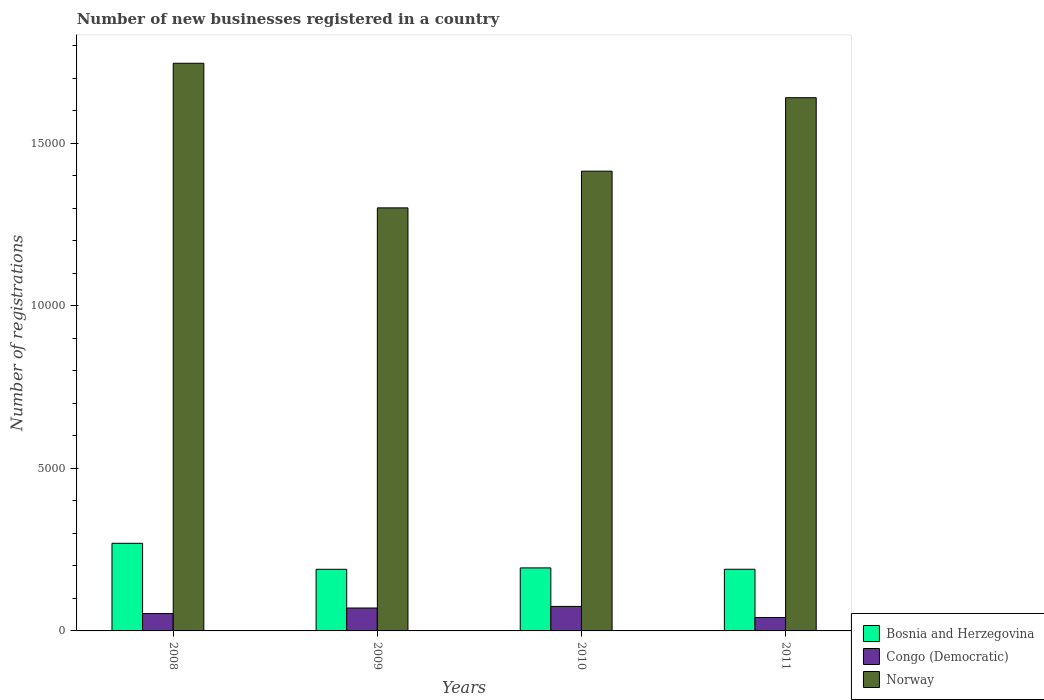How many different coloured bars are there?
Provide a short and direct response. 3. Are the number of bars per tick equal to the number of legend labels?
Ensure brevity in your answer.  Yes. How many bars are there on the 3rd tick from the right?
Offer a terse response. 3. What is the label of the 4th group of bars from the left?
Your answer should be very brief. 2011. In how many cases, is the number of bars for a given year not equal to the number of legend labels?
Give a very brief answer. 0. What is the number of new businesses registered in Bosnia and Herzegovina in 2009?
Your response must be concise. 1896. Across all years, what is the maximum number of new businesses registered in Bosnia and Herzegovina?
Offer a very short reply. 2696. Across all years, what is the minimum number of new businesses registered in Bosnia and Herzegovina?
Offer a very short reply. 1896. In which year was the number of new businesses registered in Norway maximum?
Offer a terse response. 2008. What is the total number of new businesses registered in Norway in the graph?
Ensure brevity in your answer.  6.10e+04. What is the difference between the number of new businesses registered in Bosnia and Herzegovina in 2009 and that in 2010?
Ensure brevity in your answer.  -43. What is the difference between the number of new businesses registered in Congo (Democratic) in 2008 and the number of new businesses registered in Bosnia and Herzegovina in 2010?
Give a very brief answer. -1405. What is the average number of new businesses registered in Congo (Democratic) per year?
Give a very brief answer. 601.5. In the year 2008, what is the difference between the number of new businesses registered in Congo (Democratic) and number of new businesses registered in Norway?
Offer a terse response. -1.69e+04. In how many years, is the number of new businesses registered in Norway greater than 9000?
Offer a very short reply. 4. What is the ratio of the number of new businesses registered in Congo (Democratic) in 2008 to that in 2011?
Offer a very short reply. 1.29. Is the number of new businesses registered in Norway in 2009 less than that in 2010?
Provide a succinct answer. Yes. What is the difference between the highest and the second highest number of new businesses registered in Bosnia and Herzegovina?
Provide a succinct answer. 757. What is the difference between the highest and the lowest number of new businesses registered in Norway?
Your response must be concise. 4449. What does the 1st bar from the left in 2011 represents?
Offer a terse response. Bosnia and Herzegovina. What does the 1st bar from the right in 2008 represents?
Make the answer very short. Norway. Is it the case that in every year, the sum of the number of new businesses registered in Congo (Democratic) and number of new businesses registered in Bosnia and Herzegovina is greater than the number of new businesses registered in Norway?
Provide a succinct answer. No. How many bars are there?
Ensure brevity in your answer.  12. Are all the bars in the graph horizontal?
Ensure brevity in your answer.  No. How many years are there in the graph?
Your answer should be compact. 4. What is the difference between two consecutive major ticks on the Y-axis?
Give a very brief answer. 5000. Does the graph contain any zero values?
Keep it short and to the point. No. Does the graph contain grids?
Your response must be concise. No. How many legend labels are there?
Ensure brevity in your answer.  3. What is the title of the graph?
Offer a very short reply. Number of new businesses registered in a country. Does "Middle East & North Africa (developing only)" appear as one of the legend labels in the graph?
Make the answer very short. No. What is the label or title of the X-axis?
Your answer should be compact. Years. What is the label or title of the Y-axis?
Keep it short and to the point. Number of registrations. What is the Number of registrations in Bosnia and Herzegovina in 2008?
Offer a terse response. 2696. What is the Number of registrations in Congo (Democratic) in 2008?
Offer a very short reply. 534. What is the Number of registrations of Norway in 2008?
Your answer should be compact. 1.75e+04. What is the Number of registrations in Bosnia and Herzegovina in 2009?
Make the answer very short. 1896. What is the Number of registrations of Congo (Democratic) in 2009?
Your response must be concise. 705. What is the Number of registrations in Norway in 2009?
Give a very brief answer. 1.30e+04. What is the Number of registrations in Bosnia and Herzegovina in 2010?
Offer a very short reply. 1939. What is the Number of registrations of Congo (Democratic) in 2010?
Provide a succinct answer. 754. What is the Number of registrations in Norway in 2010?
Your answer should be very brief. 1.41e+04. What is the Number of registrations of Bosnia and Herzegovina in 2011?
Your answer should be compact. 1897. What is the Number of registrations of Congo (Democratic) in 2011?
Offer a terse response. 413. What is the Number of registrations in Norway in 2011?
Provide a succinct answer. 1.64e+04. Across all years, what is the maximum Number of registrations in Bosnia and Herzegovina?
Your response must be concise. 2696. Across all years, what is the maximum Number of registrations of Congo (Democratic)?
Ensure brevity in your answer.  754. Across all years, what is the maximum Number of registrations in Norway?
Make the answer very short. 1.75e+04. Across all years, what is the minimum Number of registrations of Bosnia and Herzegovina?
Ensure brevity in your answer.  1896. Across all years, what is the minimum Number of registrations in Congo (Democratic)?
Offer a very short reply. 413. Across all years, what is the minimum Number of registrations in Norway?
Keep it short and to the point. 1.30e+04. What is the total Number of registrations in Bosnia and Herzegovina in the graph?
Your answer should be very brief. 8428. What is the total Number of registrations of Congo (Democratic) in the graph?
Offer a terse response. 2406. What is the total Number of registrations in Norway in the graph?
Offer a terse response. 6.10e+04. What is the difference between the Number of registrations of Bosnia and Herzegovina in 2008 and that in 2009?
Your answer should be very brief. 800. What is the difference between the Number of registrations in Congo (Democratic) in 2008 and that in 2009?
Make the answer very short. -171. What is the difference between the Number of registrations of Norway in 2008 and that in 2009?
Offer a very short reply. 4449. What is the difference between the Number of registrations of Bosnia and Herzegovina in 2008 and that in 2010?
Your response must be concise. 757. What is the difference between the Number of registrations of Congo (Democratic) in 2008 and that in 2010?
Your response must be concise. -220. What is the difference between the Number of registrations in Norway in 2008 and that in 2010?
Your answer should be compact. 3320. What is the difference between the Number of registrations in Bosnia and Herzegovina in 2008 and that in 2011?
Provide a succinct answer. 799. What is the difference between the Number of registrations of Congo (Democratic) in 2008 and that in 2011?
Give a very brief answer. 121. What is the difference between the Number of registrations of Norway in 2008 and that in 2011?
Give a very brief answer. 1060. What is the difference between the Number of registrations in Bosnia and Herzegovina in 2009 and that in 2010?
Provide a succinct answer. -43. What is the difference between the Number of registrations of Congo (Democratic) in 2009 and that in 2010?
Your response must be concise. -49. What is the difference between the Number of registrations in Norway in 2009 and that in 2010?
Provide a short and direct response. -1129. What is the difference between the Number of registrations of Congo (Democratic) in 2009 and that in 2011?
Provide a succinct answer. 292. What is the difference between the Number of registrations in Norway in 2009 and that in 2011?
Your answer should be very brief. -3389. What is the difference between the Number of registrations of Congo (Democratic) in 2010 and that in 2011?
Offer a terse response. 341. What is the difference between the Number of registrations of Norway in 2010 and that in 2011?
Offer a very short reply. -2260. What is the difference between the Number of registrations of Bosnia and Herzegovina in 2008 and the Number of registrations of Congo (Democratic) in 2009?
Your answer should be compact. 1991. What is the difference between the Number of registrations of Bosnia and Herzegovina in 2008 and the Number of registrations of Norway in 2009?
Your answer should be very brief. -1.03e+04. What is the difference between the Number of registrations in Congo (Democratic) in 2008 and the Number of registrations in Norway in 2009?
Offer a very short reply. -1.25e+04. What is the difference between the Number of registrations in Bosnia and Herzegovina in 2008 and the Number of registrations in Congo (Democratic) in 2010?
Keep it short and to the point. 1942. What is the difference between the Number of registrations in Bosnia and Herzegovina in 2008 and the Number of registrations in Norway in 2010?
Provide a succinct answer. -1.14e+04. What is the difference between the Number of registrations in Congo (Democratic) in 2008 and the Number of registrations in Norway in 2010?
Ensure brevity in your answer.  -1.36e+04. What is the difference between the Number of registrations of Bosnia and Herzegovina in 2008 and the Number of registrations of Congo (Democratic) in 2011?
Your answer should be very brief. 2283. What is the difference between the Number of registrations in Bosnia and Herzegovina in 2008 and the Number of registrations in Norway in 2011?
Keep it short and to the point. -1.37e+04. What is the difference between the Number of registrations of Congo (Democratic) in 2008 and the Number of registrations of Norway in 2011?
Your response must be concise. -1.59e+04. What is the difference between the Number of registrations in Bosnia and Herzegovina in 2009 and the Number of registrations in Congo (Democratic) in 2010?
Offer a very short reply. 1142. What is the difference between the Number of registrations in Bosnia and Herzegovina in 2009 and the Number of registrations in Norway in 2010?
Your answer should be compact. -1.22e+04. What is the difference between the Number of registrations of Congo (Democratic) in 2009 and the Number of registrations of Norway in 2010?
Ensure brevity in your answer.  -1.34e+04. What is the difference between the Number of registrations of Bosnia and Herzegovina in 2009 and the Number of registrations of Congo (Democratic) in 2011?
Provide a short and direct response. 1483. What is the difference between the Number of registrations of Bosnia and Herzegovina in 2009 and the Number of registrations of Norway in 2011?
Ensure brevity in your answer.  -1.45e+04. What is the difference between the Number of registrations of Congo (Democratic) in 2009 and the Number of registrations of Norway in 2011?
Provide a succinct answer. -1.57e+04. What is the difference between the Number of registrations in Bosnia and Herzegovina in 2010 and the Number of registrations in Congo (Democratic) in 2011?
Offer a very short reply. 1526. What is the difference between the Number of registrations of Bosnia and Herzegovina in 2010 and the Number of registrations of Norway in 2011?
Your response must be concise. -1.45e+04. What is the difference between the Number of registrations of Congo (Democratic) in 2010 and the Number of registrations of Norway in 2011?
Keep it short and to the point. -1.57e+04. What is the average Number of registrations of Bosnia and Herzegovina per year?
Your answer should be very brief. 2107. What is the average Number of registrations of Congo (Democratic) per year?
Keep it short and to the point. 601.5. What is the average Number of registrations in Norway per year?
Make the answer very short. 1.53e+04. In the year 2008, what is the difference between the Number of registrations in Bosnia and Herzegovina and Number of registrations in Congo (Democratic)?
Make the answer very short. 2162. In the year 2008, what is the difference between the Number of registrations of Bosnia and Herzegovina and Number of registrations of Norway?
Provide a short and direct response. -1.48e+04. In the year 2008, what is the difference between the Number of registrations in Congo (Democratic) and Number of registrations in Norway?
Provide a short and direct response. -1.69e+04. In the year 2009, what is the difference between the Number of registrations in Bosnia and Herzegovina and Number of registrations in Congo (Democratic)?
Provide a short and direct response. 1191. In the year 2009, what is the difference between the Number of registrations in Bosnia and Herzegovina and Number of registrations in Norway?
Ensure brevity in your answer.  -1.11e+04. In the year 2009, what is the difference between the Number of registrations of Congo (Democratic) and Number of registrations of Norway?
Offer a very short reply. -1.23e+04. In the year 2010, what is the difference between the Number of registrations of Bosnia and Herzegovina and Number of registrations of Congo (Democratic)?
Your response must be concise. 1185. In the year 2010, what is the difference between the Number of registrations of Bosnia and Herzegovina and Number of registrations of Norway?
Ensure brevity in your answer.  -1.22e+04. In the year 2010, what is the difference between the Number of registrations of Congo (Democratic) and Number of registrations of Norway?
Your answer should be compact. -1.34e+04. In the year 2011, what is the difference between the Number of registrations of Bosnia and Herzegovina and Number of registrations of Congo (Democratic)?
Provide a succinct answer. 1484. In the year 2011, what is the difference between the Number of registrations in Bosnia and Herzegovina and Number of registrations in Norway?
Provide a succinct answer. -1.45e+04. In the year 2011, what is the difference between the Number of registrations in Congo (Democratic) and Number of registrations in Norway?
Offer a very short reply. -1.60e+04. What is the ratio of the Number of registrations in Bosnia and Herzegovina in 2008 to that in 2009?
Offer a terse response. 1.42. What is the ratio of the Number of registrations in Congo (Democratic) in 2008 to that in 2009?
Your response must be concise. 0.76. What is the ratio of the Number of registrations of Norway in 2008 to that in 2009?
Your answer should be compact. 1.34. What is the ratio of the Number of registrations in Bosnia and Herzegovina in 2008 to that in 2010?
Your answer should be compact. 1.39. What is the ratio of the Number of registrations of Congo (Democratic) in 2008 to that in 2010?
Your answer should be compact. 0.71. What is the ratio of the Number of registrations in Norway in 2008 to that in 2010?
Make the answer very short. 1.23. What is the ratio of the Number of registrations in Bosnia and Herzegovina in 2008 to that in 2011?
Offer a terse response. 1.42. What is the ratio of the Number of registrations in Congo (Democratic) in 2008 to that in 2011?
Offer a terse response. 1.29. What is the ratio of the Number of registrations in Norway in 2008 to that in 2011?
Offer a terse response. 1.06. What is the ratio of the Number of registrations of Bosnia and Herzegovina in 2009 to that in 2010?
Offer a terse response. 0.98. What is the ratio of the Number of registrations in Congo (Democratic) in 2009 to that in 2010?
Give a very brief answer. 0.94. What is the ratio of the Number of registrations of Norway in 2009 to that in 2010?
Provide a short and direct response. 0.92. What is the ratio of the Number of registrations of Bosnia and Herzegovina in 2009 to that in 2011?
Make the answer very short. 1. What is the ratio of the Number of registrations of Congo (Democratic) in 2009 to that in 2011?
Ensure brevity in your answer.  1.71. What is the ratio of the Number of registrations of Norway in 2009 to that in 2011?
Your answer should be very brief. 0.79. What is the ratio of the Number of registrations of Bosnia and Herzegovina in 2010 to that in 2011?
Offer a very short reply. 1.02. What is the ratio of the Number of registrations in Congo (Democratic) in 2010 to that in 2011?
Give a very brief answer. 1.83. What is the ratio of the Number of registrations in Norway in 2010 to that in 2011?
Provide a succinct answer. 0.86. What is the difference between the highest and the second highest Number of registrations in Bosnia and Herzegovina?
Provide a short and direct response. 757. What is the difference between the highest and the second highest Number of registrations of Norway?
Make the answer very short. 1060. What is the difference between the highest and the lowest Number of registrations in Bosnia and Herzegovina?
Offer a terse response. 800. What is the difference between the highest and the lowest Number of registrations of Congo (Democratic)?
Offer a terse response. 341. What is the difference between the highest and the lowest Number of registrations in Norway?
Offer a very short reply. 4449. 